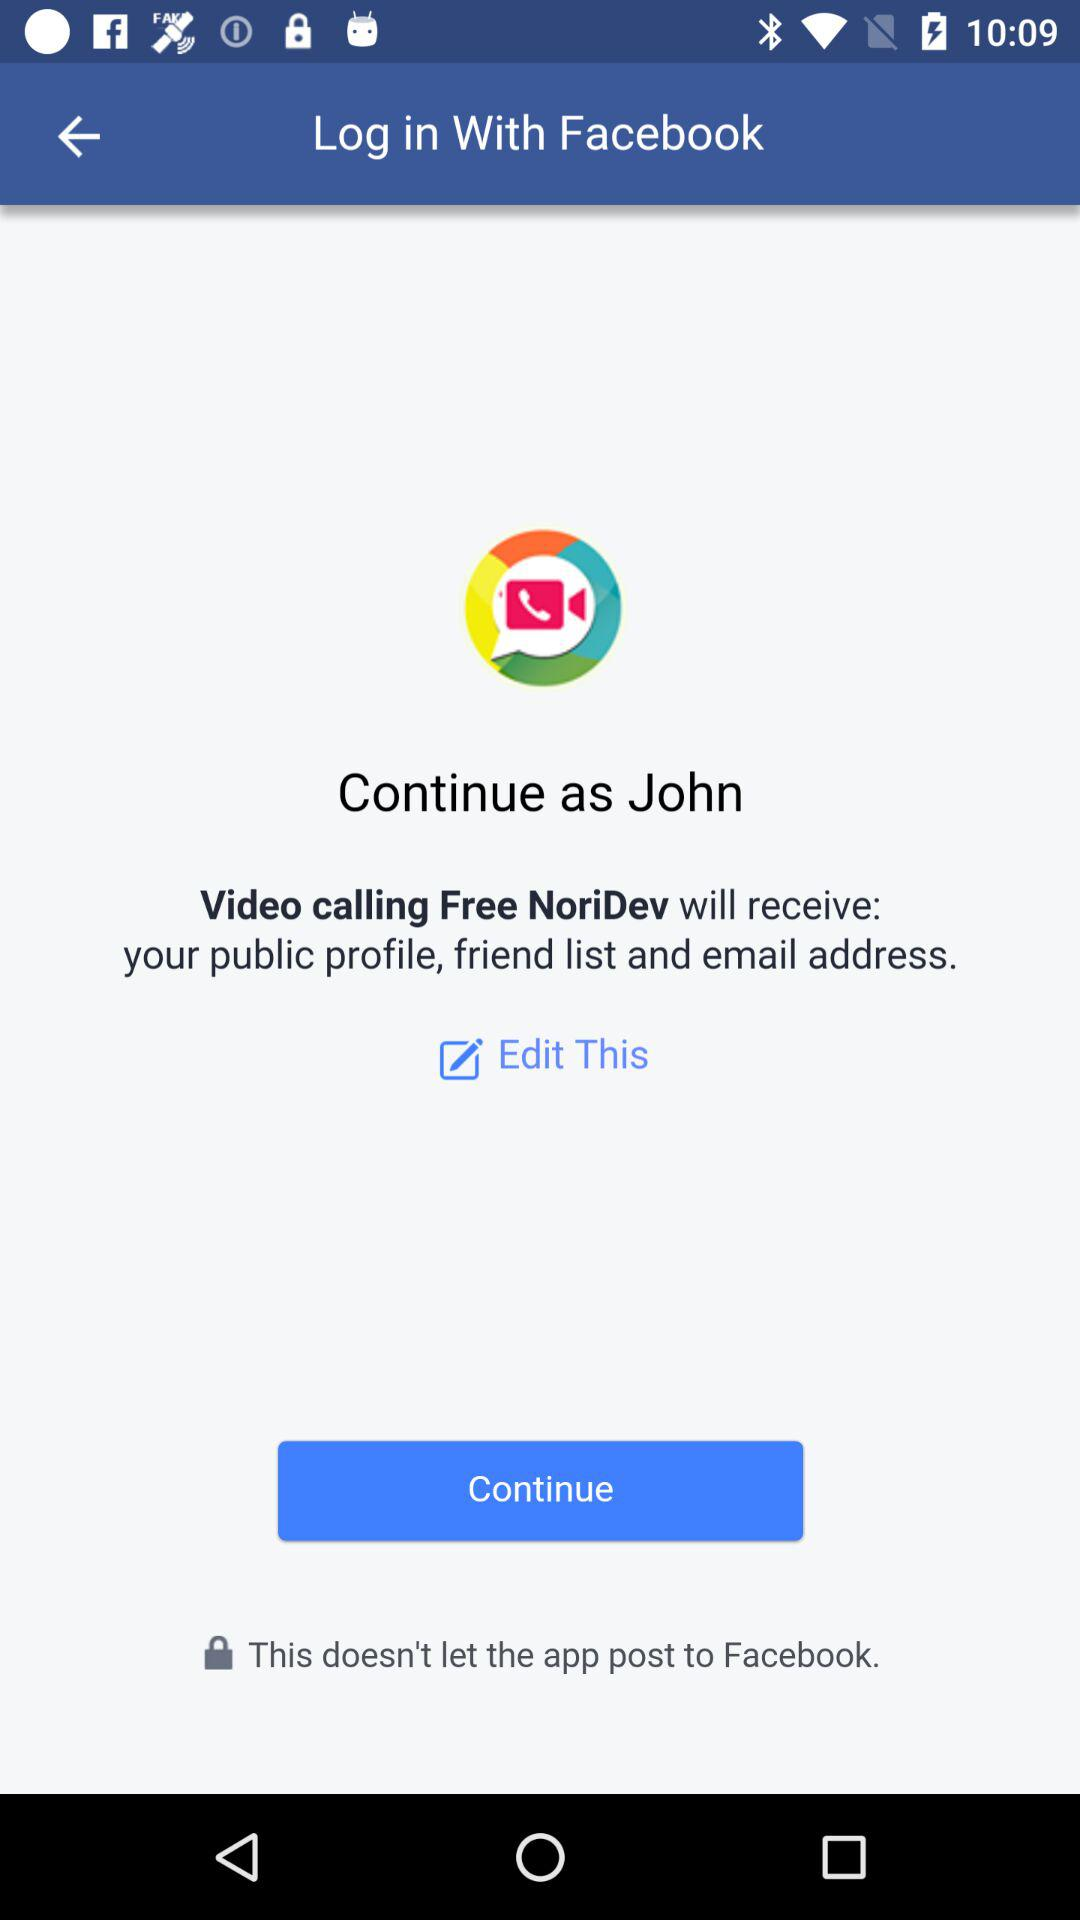What is the login profile name? The login profile name is John. 